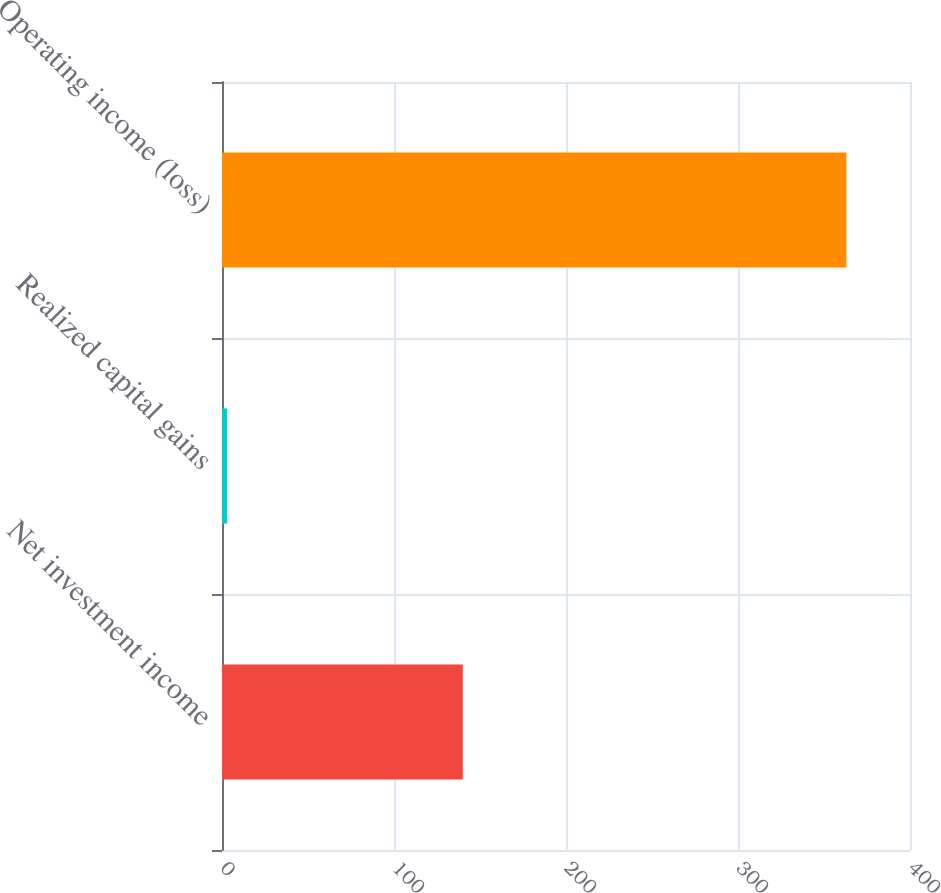Convert chart. <chart><loc_0><loc_0><loc_500><loc_500><bar_chart><fcel>Net investment income<fcel>Realized capital gains<fcel>Operating income (loss)<nl><fcel>140<fcel>3<fcel>363<nl></chart> 